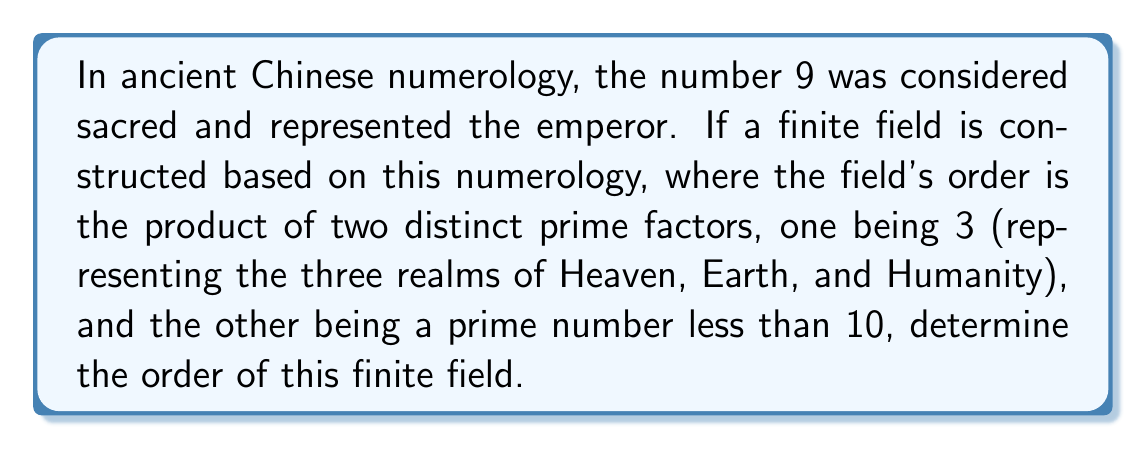Help me with this question. To solve this problem, we need to follow these steps:

1) We know that the order of the field is the product of two distinct prime factors.

2) One of these factors is given as 3.

3) The other factor is a prime number less than 10.

4) The prime numbers less than 10 are: 2, 3, 5, 7

5) We can't use 3 again as the factors need to be distinct.

6) Among the remaining options (2, 5, 7), we need to choose the one that, when multiplied by 3, gives us a number that incorporates the sacred number 9.

7) Let's check each option:
   
   $3 \times 2 = 6$ (doesn't include 9)
   $3 \times 5 = 15$ (doesn't include 9)
   $3 \times 7 = 21$ (includes 9 as a factor)

8) Therefore, the prime number we're looking for is 7.

9) The order of the finite field is thus:

   $$ |F| = 3 \times 7 = 21 $$

This satisfies all conditions: it's the product of two distinct primes, one is 3, the other is less than 10, and the result incorporates the sacred number 9 (as 21 is a multiple of 9).
Answer: 21 